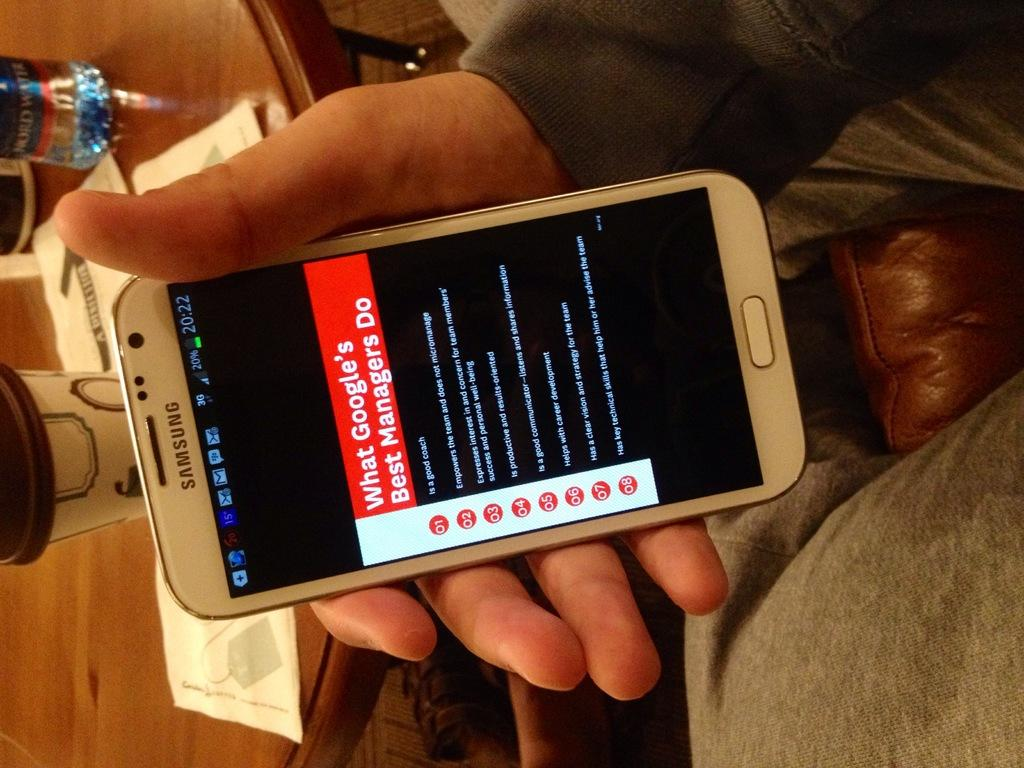<image>
Render a clear and concise summary of the photo. White Samsung phone home screen showing " What Googles Best Managers Do". 